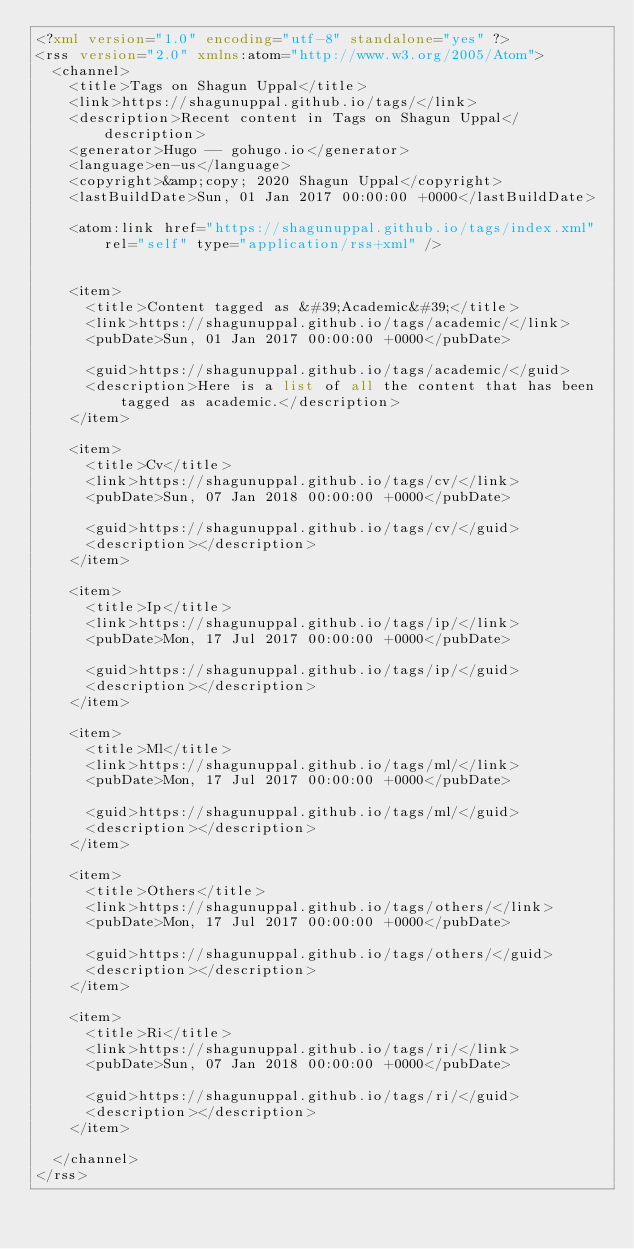<code> <loc_0><loc_0><loc_500><loc_500><_XML_><?xml version="1.0" encoding="utf-8" standalone="yes" ?>
<rss version="2.0" xmlns:atom="http://www.w3.org/2005/Atom">
  <channel>
    <title>Tags on Shagun Uppal</title>
    <link>https://shagunuppal.github.io/tags/</link>
    <description>Recent content in Tags on Shagun Uppal</description>
    <generator>Hugo -- gohugo.io</generator>
    <language>en-us</language>
    <copyright>&amp;copy; 2020 Shagun Uppal</copyright>
    <lastBuildDate>Sun, 01 Jan 2017 00:00:00 +0000</lastBuildDate>
    
	<atom:link href="https://shagunuppal.github.io/tags/index.xml" rel="self" type="application/rss+xml" />
    
    
    <item>
      <title>Content tagged as &#39;Academic&#39;</title>
      <link>https://shagunuppal.github.io/tags/academic/</link>
      <pubDate>Sun, 01 Jan 2017 00:00:00 +0000</pubDate>
      
      <guid>https://shagunuppal.github.io/tags/academic/</guid>
      <description>Here is a list of all the content that has been tagged as academic.</description>
    </item>
    
    <item>
      <title>Cv</title>
      <link>https://shagunuppal.github.io/tags/cv/</link>
      <pubDate>Sun, 07 Jan 2018 00:00:00 +0000</pubDate>
      
      <guid>https://shagunuppal.github.io/tags/cv/</guid>
      <description></description>
    </item>
    
    <item>
      <title>Ip</title>
      <link>https://shagunuppal.github.io/tags/ip/</link>
      <pubDate>Mon, 17 Jul 2017 00:00:00 +0000</pubDate>
      
      <guid>https://shagunuppal.github.io/tags/ip/</guid>
      <description></description>
    </item>
    
    <item>
      <title>Ml</title>
      <link>https://shagunuppal.github.io/tags/ml/</link>
      <pubDate>Mon, 17 Jul 2017 00:00:00 +0000</pubDate>
      
      <guid>https://shagunuppal.github.io/tags/ml/</guid>
      <description></description>
    </item>
    
    <item>
      <title>Others</title>
      <link>https://shagunuppal.github.io/tags/others/</link>
      <pubDate>Mon, 17 Jul 2017 00:00:00 +0000</pubDate>
      
      <guid>https://shagunuppal.github.io/tags/others/</guid>
      <description></description>
    </item>
    
    <item>
      <title>Ri</title>
      <link>https://shagunuppal.github.io/tags/ri/</link>
      <pubDate>Sun, 07 Jan 2018 00:00:00 +0000</pubDate>
      
      <guid>https://shagunuppal.github.io/tags/ri/</guid>
      <description></description>
    </item>
    
  </channel>
</rss></code> 